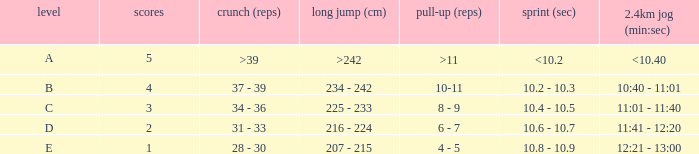Tell me the 2.4km run for points less than 2 12:21 - 13:00. 